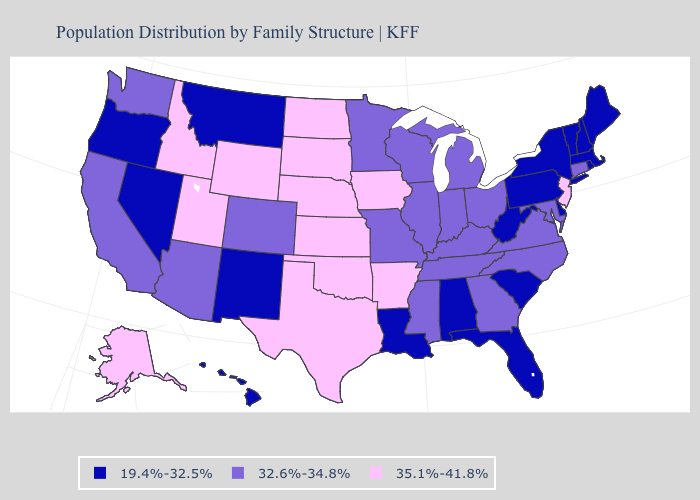What is the value of Texas?
Be succinct. 35.1%-41.8%. Name the states that have a value in the range 19.4%-32.5%?
Write a very short answer. Alabama, Delaware, Florida, Hawaii, Louisiana, Maine, Massachusetts, Montana, Nevada, New Hampshire, New Mexico, New York, Oregon, Pennsylvania, Rhode Island, South Carolina, Vermont, West Virginia. Name the states that have a value in the range 19.4%-32.5%?
Quick response, please. Alabama, Delaware, Florida, Hawaii, Louisiana, Maine, Massachusetts, Montana, Nevada, New Hampshire, New Mexico, New York, Oregon, Pennsylvania, Rhode Island, South Carolina, Vermont, West Virginia. Among the states that border Washington , which have the lowest value?
Give a very brief answer. Oregon. Name the states that have a value in the range 19.4%-32.5%?
Be succinct. Alabama, Delaware, Florida, Hawaii, Louisiana, Maine, Massachusetts, Montana, Nevada, New Hampshire, New Mexico, New York, Oregon, Pennsylvania, Rhode Island, South Carolina, Vermont, West Virginia. Is the legend a continuous bar?
Keep it brief. No. Name the states that have a value in the range 19.4%-32.5%?
Quick response, please. Alabama, Delaware, Florida, Hawaii, Louisiana, Maine, Massachusetts, Montana, Nevada, New Hampshire, New Mexico, New York, Oregon, Pennsylvania, Rhode Island, South Carolina, Vermont, West Virginia. Name the states that have a value in the range 32.6%-34.8%?
Be succinct. Arizona, California, Colorado, Connecticut, Georgia, Illinois, Indiana, Kentucky, Maryland, Michigan, Minnesota, Mississippi, Missouri, North Carolina, Ohio, Tennessee, Virginia, Washington, Wisconsin. Name the states that have a value in the range 35.1%-41.8%?
Keep it brief. Alaska, Arkansas, Idaho, Iowa, Kansas, Nebraska, New Jersey, North Dakota, Oklahoma, South Dakota, Texas, Utah, Wyoming. Does the first symbol in the legend represent the smallest category?
Quick response, please. Yes. What is the lowest value in the USA?
Concise answer only. 19.4%-32.5%. Name the states that have a value in the range 35.1%-41.8%?
Quick response, please. Alaska, Arkansas, Idaho, Iowa, Kansas, Nebraska, New Jersey, North Dakota, Oklahoma, South Dakota, Texas, Utah, Wyoming. Name the states that have a value in the range 19.4%-32.5%?
Write a very short answer. Alabama, Delaware, Florida, Hawaii, Louisiana, Maine, Massachusetts, Montana, Nevada, New Hampshire, New Mexico, New York, Oregon, Pennsylvania, Rhode Island, South Carolina, Vermont, West Virginia. Name the states that have a value in the range 35.1%-41.8%?
Keep it brief. Alaska, Arkansas, Idaho, Iowa, Kansas, Nebraska, New Jersey, North Dakota, Oklahoma, South Dakota, Texas, Utah, Wyoming. Name the states that have a value in the range 35.1%-41.8%?
Quick response, please. Alaska, Arkansas, Idaho, Iowa, Kansas, Nebraska, New Jersey, North Dakota, Oklahoma, South Dakota, Texas, Utah, Wyoming. 